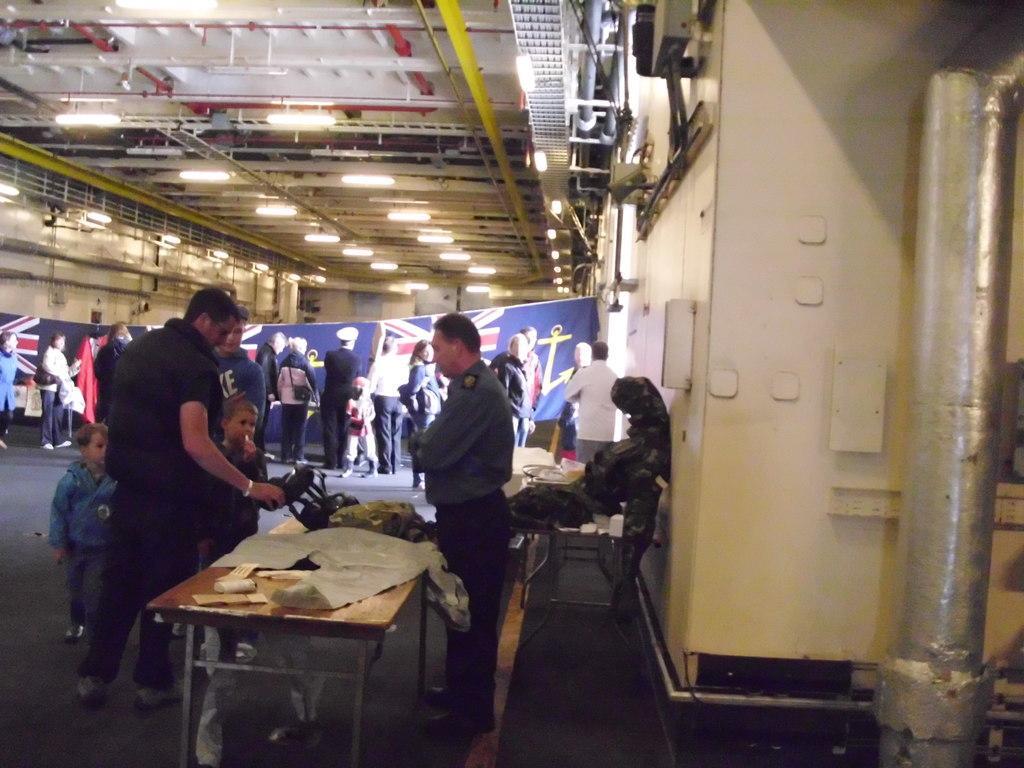In one or two sentences, can you explain what this image depicts? In this image I can see number of people are standing, here I can see he is wearing a uniform. I can also see few tables and on this table I can see few stuffs. In the background I can see flag and here on ceiling I can see lights. 